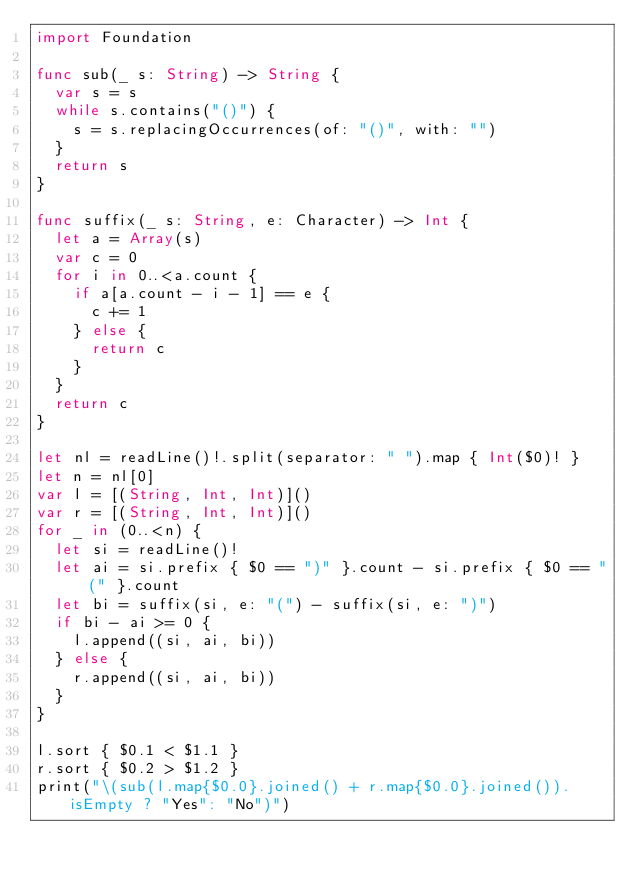<code> <loc_0><loc_0><loc_500><loc_500><_Swift_>import Foundation

func sub(_ s: String) -> String {
  var s = s
  while s.contains("()") {
    s = s.replacingOccurrences(of: "()", with: "")
  }
  return s
}

func suffix(_ s: String, e: Character) -> Int {
  let a = Array(s)
  var c = 0
  for i in 0..<a.count {
    if a[a.count - i - 1] == e {
      c += 1
    } else {
      return c
    }
  }
  return c
}

let nl = readLine()!.split(separator: " ").map { Int($0)! }
let n = nl[0]
var l = [(String, Int, Int)]()
var r = [(String, Int, Int)]()
for _ in (0..<n) {
  let si = readLine()!
  let ai = si.prefix { $0 == ")" }.count - si.prefix { $0 == "(" }.count
  let bi = suffix(si, e: "(") - suffix(si, e: ")")
  if bi - ai >= 0 {
    l.append((si, ai, bi))
  } else {
    r.append((si, ai, bi))
  }
}

l.sort { $0.1 < $1.1 }
r.sort { $0.2 > $1.2 }
print("\(sub(l.map{$0.0}.joined() + r.map{$0.0}.joined()).isEmpty ? "Yes": "No")")</code> 